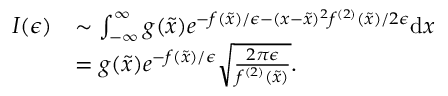<formula> <loc_0><loc_0><loc_500><loc_500>\begin{array} { r l } { I ( \epsilon ) } & { \sim \int _ { - \infty } ^ { \infty } g ( \tilde { x } ) e ^ { - f ( \tilde { x } ) / \epsilon - ( x - \tilde { x } ) ^ { 2 } f ^ { ( 2 ) } ( \tilde { x } ) / 2 \epsilon } d x } \\ & { = g ( \tilde { x } ) e ^ { - f ( \tilde { x } ) / \epsilon } \sqrt { \frac { 2 \pi \epsilon } { f ^ { ( 2 ) } ( \tilde { x } ) } } . } \end{array}</formula> 